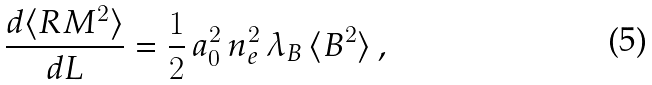Convert formula to latex. <formula><loc_0><loc_0><loc_500><loc_500>\frac { d \langle R M ^ { 2 } \rangle } { d L } = \frac { 1 } { 2 } \, a _ { 0 } ^ { 2 } \, n _ { e } ^ { 2 } \, \lambda _ { B } \, \langle B ^ { 2 } \rangle \, ,</formula> 